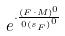Convert formula to latex. <formula><loc_0><loc_0><loc_500><loc_500>e ^ { \cdot \frac { ( F \cdot M ) ^ { 0 } } { 0 { ( s _ { F } ) } ^ { 0 } } }</formula> 